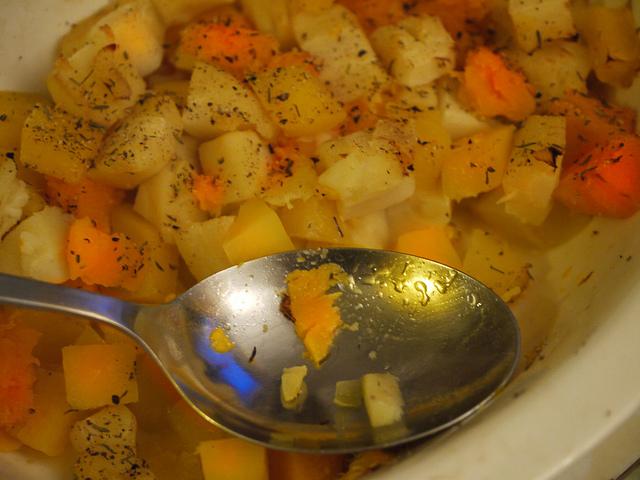Are these apples cooked?
Answer briefly. Yes. What utensil is in the picture?
Be succinct. Spoon. Did part of this meal come from a cow?
Be succinct. No. Is the spoon clean?
Short answer required. No. Is this a piece of cake?
Answer briefly. No. What is in the bowl?
Give a very brief answer. Potatoes. How many spoons are there?
Be succinct. 1. What is the orange colored food?
Concise answer only. Carrots. What types of fruits are here?
Keep it brief. None. 